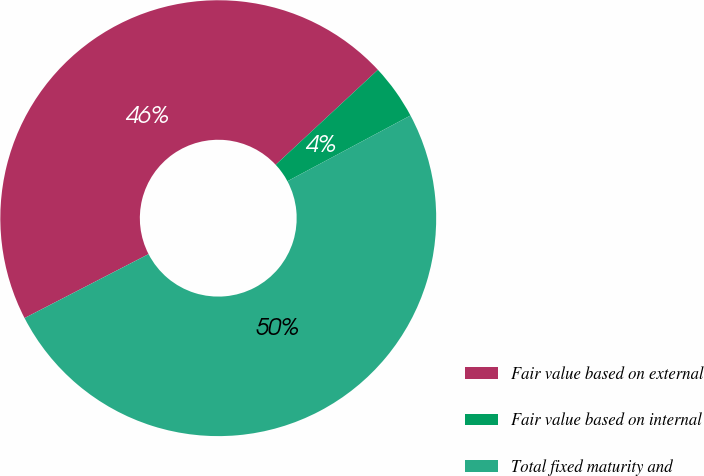Convert chart to OTSL. <chart><loc_0><loc_0><loc_500><loc_500><pie_chart><fcel>Fair value based on external<fcel>Fair value based on internal<fcel>Total fixed maturity and<nl><fcel>45.66%<fcel>4.11%<fcel>50.23%<nl></chart> 